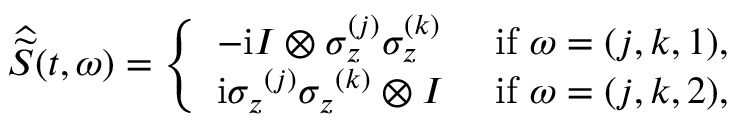<formula> <loc_0><loc_0><loc_500><loc_500>\widehat { \widetilde { S } } ( t , \omega ) = \left \{ \begin{array} { l l } { - i I \otimes \sigma _ { z } ^ { ( j ) } \sigma _ { z } ^ { ( k ) } } & { i f \omega = ( j , k , 1 ) , } \\ { i { \sigma _ { z } } ^ { ( j ) } { \sigma _ { z } } ^ { ( k ) } \otimes I } & { i f \omega = ( j , k , 2 ) , } \end{array}</formula> 